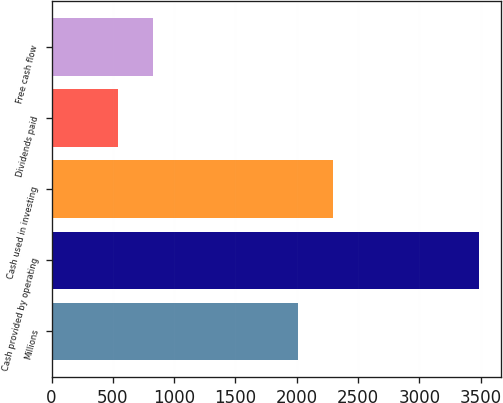Convert chart. <chart><loc_0><loc_0><loc_500><loc_500><bar_chart><fcel>Millions<fcel>Cash provided by operating<fcel>Cash used in investing<fcel>Dividends paid<fcel>Free cash flow<nl><fcel>2009<fcel>3488.4<fcel>2293.4<fcel>544<fcel>828.4<nl></chart> 